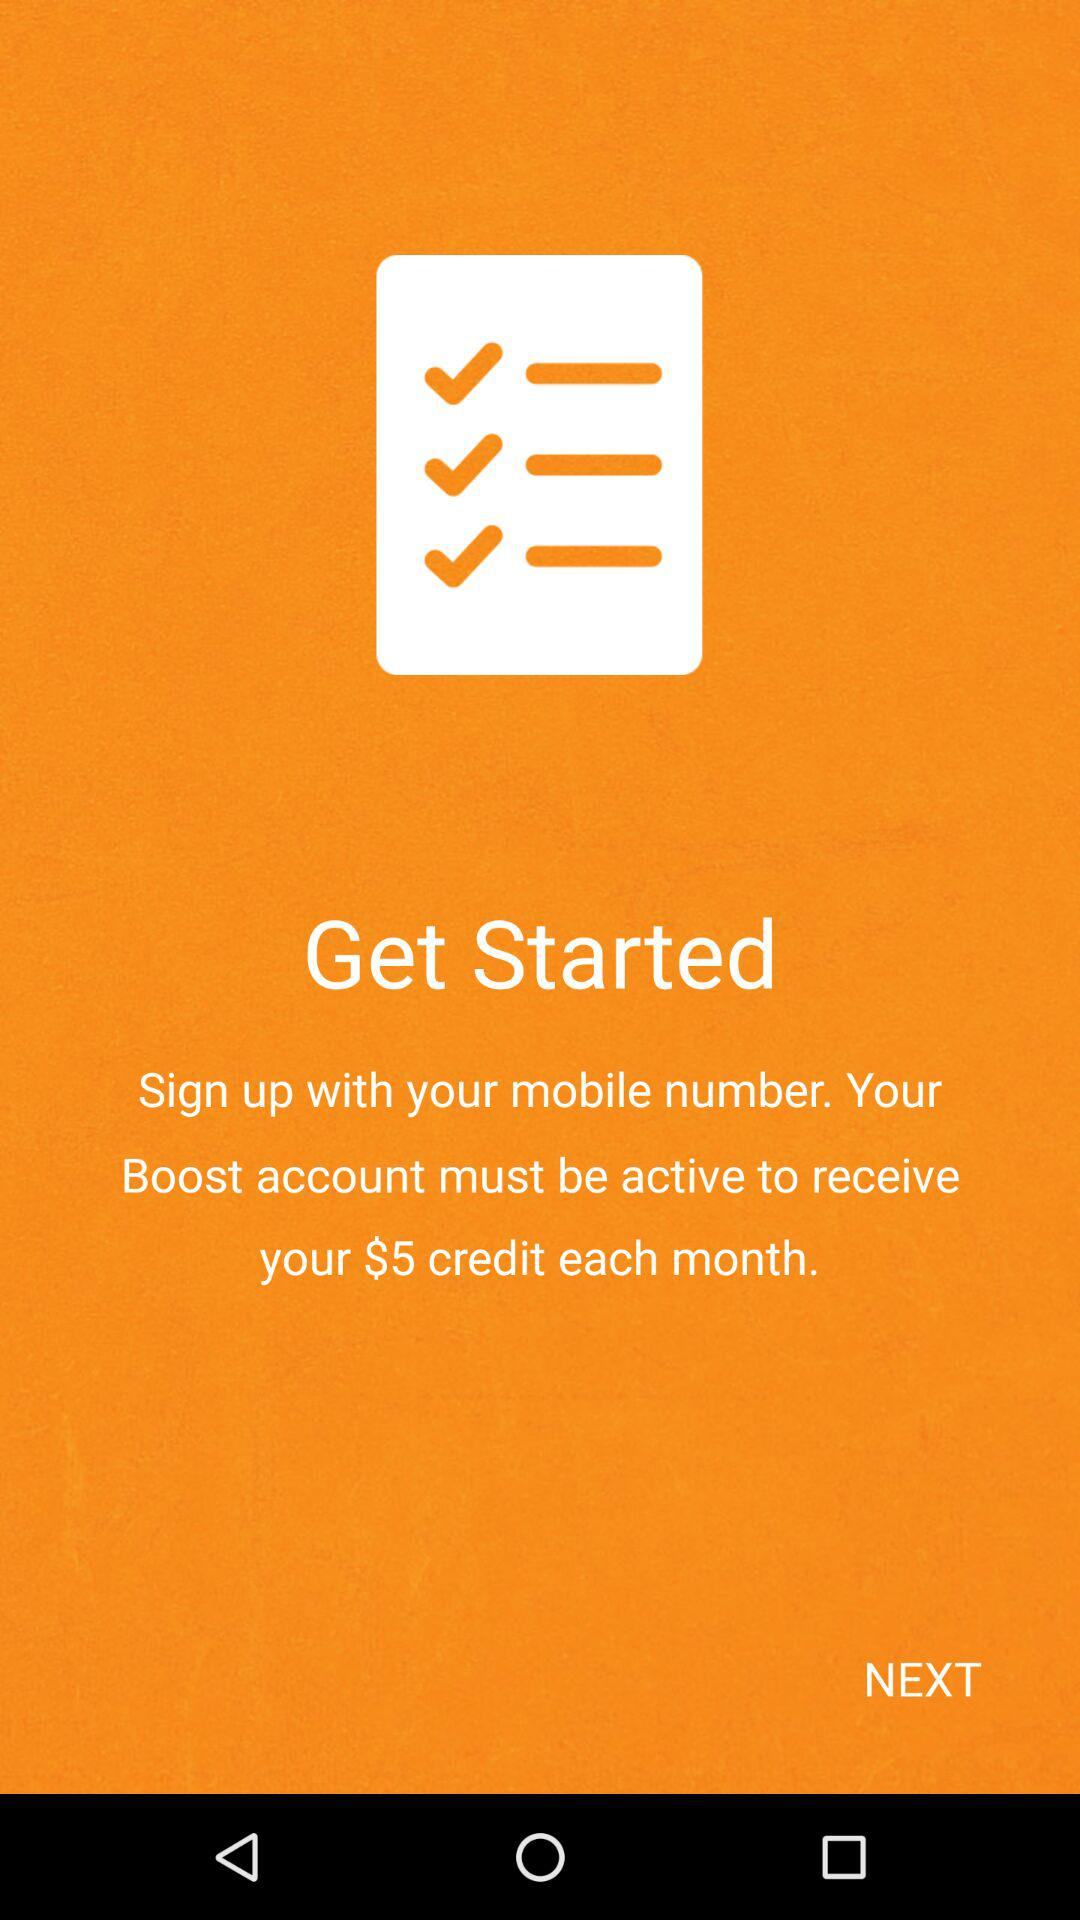What account must be active to receive a $5 credit each month? The Boost account must be active to receive a $5 credit each month. 